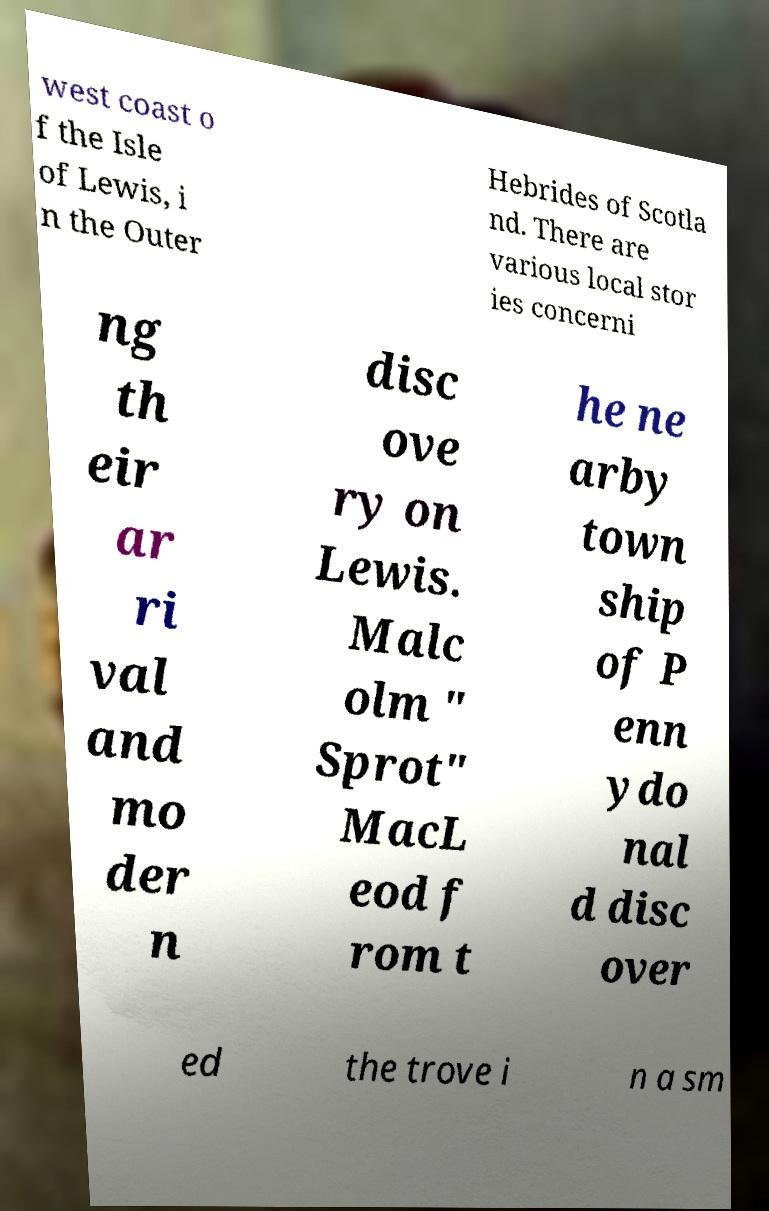Could you assist in decoding the text presented in this image and type it out clearly? west coast o f the Isle of Lewis, i n the Outer Hebrides of Scotla nd. There are various local stor ies concerni ng th eir ar ri val and mo der n disc ove ry on Lewis. Malc olm " Sprot" MacL eod f rom t he ne arby town ship of P enn ydo nal d disc over ed the trove i n a sm 